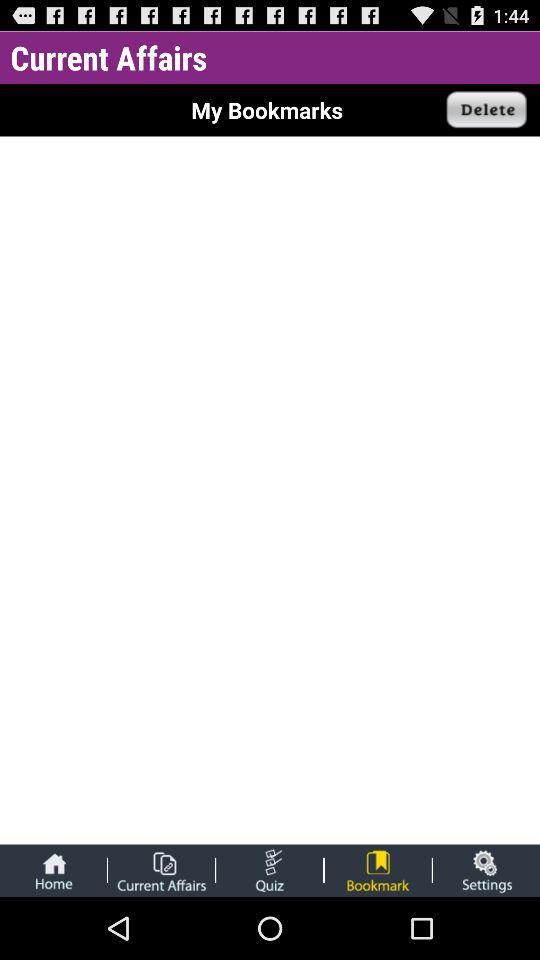Which option is selected in the tab bar? The selected option in the tab bar is "Bookmark". 